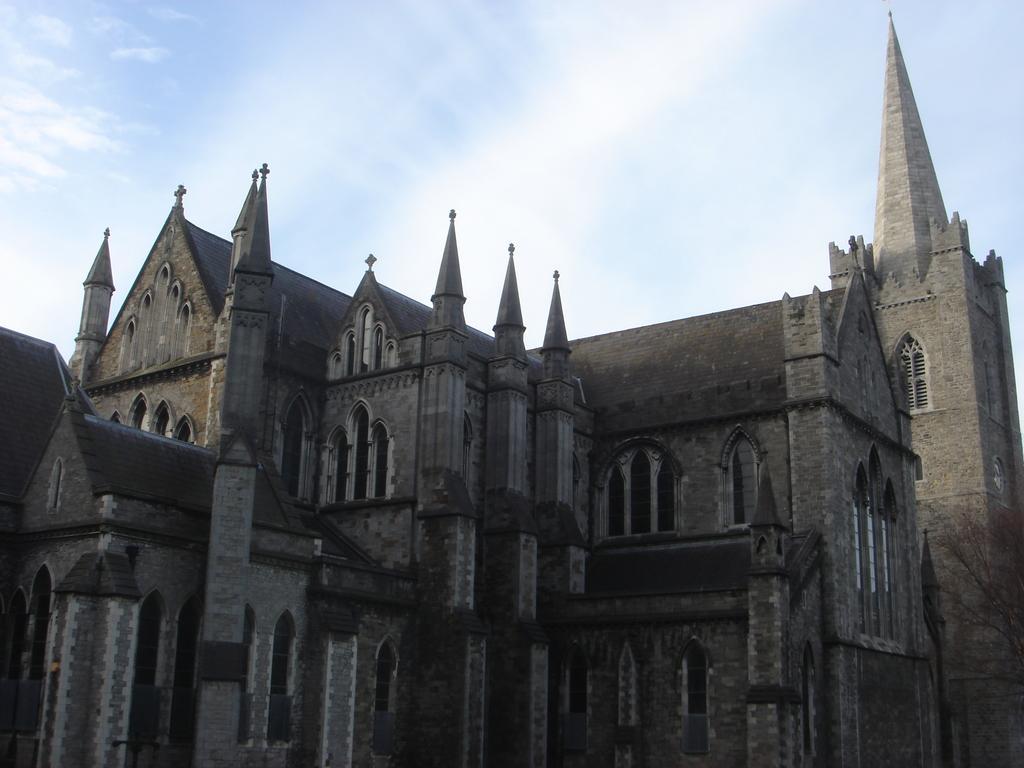In one or two sentences, can you explain what this image depicts? In this image in the center there is a palace, and also we can see some windows. At the top of the image there is sky. 